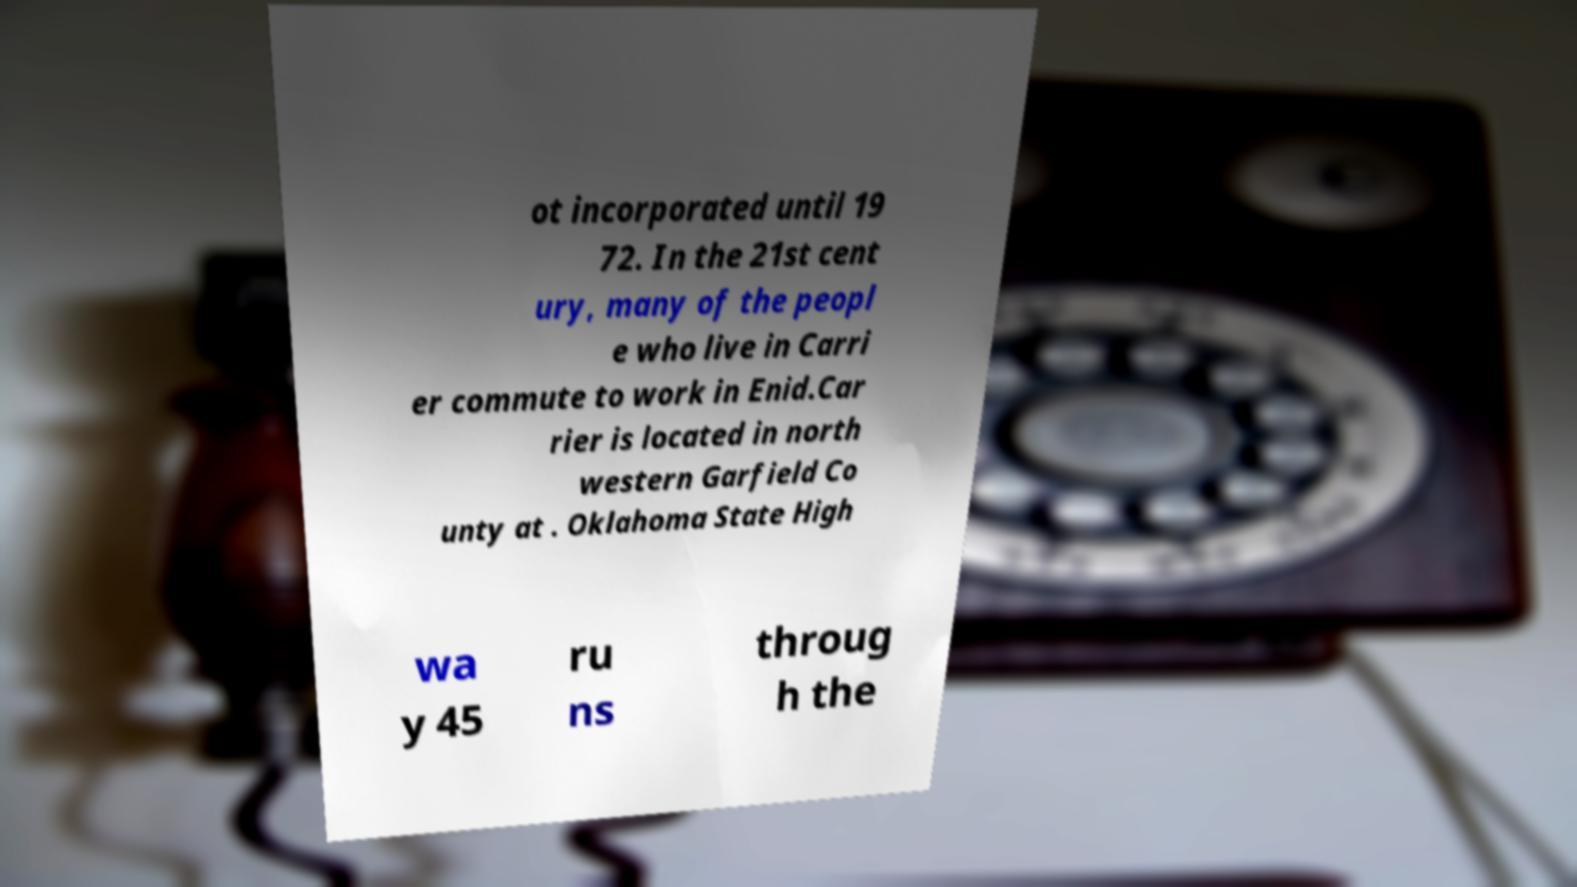Can you read and provide the text displayed in the image?This photo seems to have some interesting text. Can you extract and type it out for me? ot incorporated until 19 72. In the 21st cent ury, many of the peopl e who live in Carri er commute to work in Enid.Car rier is located in north western Garfield Co unty at . Oklahoma State High wa y 45 ru ns throug h the 